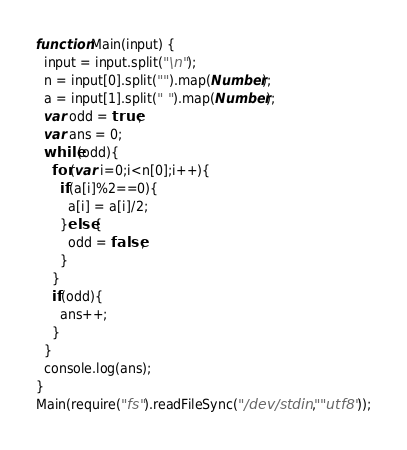<code> <loc_0><loc_0><loc_500><loc_500><_JavaScript_>function Main(input) {
  input = input.split("\n");
  n = input[0].split("").map(Number);
  a = input[1].split(" ").map(Number);
  var odd = true;
  var ans = 0;
  while(odd){
    for(var i=0;i<n[0];i++){
      if(a[i]%2==0){
        a[i] = a[i]/2;
      }else{
        odd = false;
      }
    }
    if(odd){
      ans++;
    }
  }
  console.log(ans);
}
Main(require("fs").readFileSync("/dev/stdin", "utf8"));</code> 